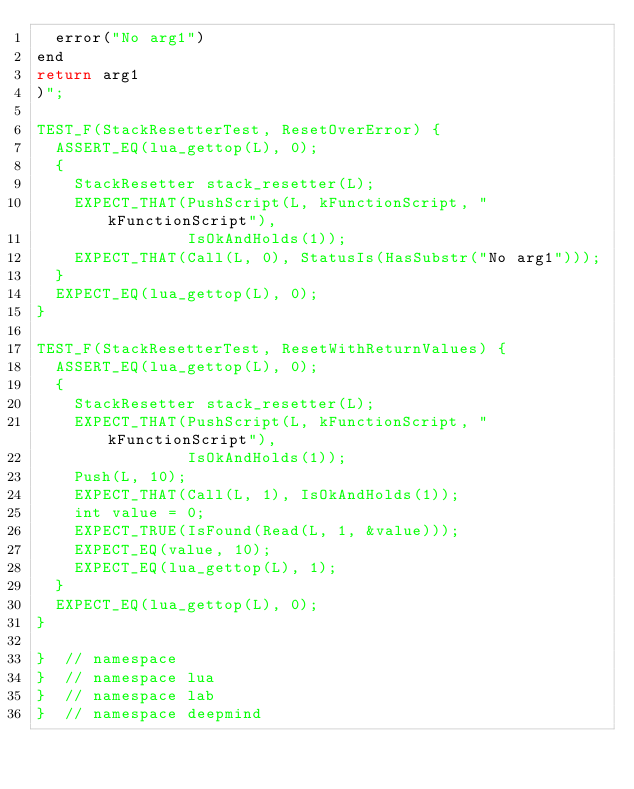Convert code to text. <code><loc_0><loc_0><loc_500><loc_500><_C++_>  error("No arg1")
end
return arg1
)";

TEST_F(StackResetterTest, ResetOverError) {
  ASSERT_EQ(lua_gettop(L), 0);
  {
    StackResetter stack_resetter(L);
    EXPECT_THAT(PushScript(L, kFunctionScript, "kFunctionScript"),
                IsOkAndHolds(1));
    EXPECT_THAT(Call(L, 0), StatusIs(HasSubstr("No arg1")));
  }
  EXPECT_EQ(lua_gettop(L), 0);
}

TEST_F(StackResetterTest, ResetWithReturnValues) {
  ASSERT_EQ(lua_gettop(L), 0);
  {
    StackResetter stack_resetter(L);
    EXPECT_THAT(PushScript(L, kFunctionScript, "kFunctionScript"),
                IsOkAndHolds(1));
    Push(L, 10);
    EXPECT_THAT(Call(L, 1), IsOkAndHolds(1));
    int value = 0;
    EXPECT_TRUE(IsFound(Read(L, 1, &value)));
    EXPECT_EQ(value, 10);
    EXPECT_EQ(lua_gettop(L), 1);
  }
  EXPECT_EQ(lua_gettop(L), 0);
}

}  // namespace
}  // namespace lua
}  // namespace lab
}  // namespace deepmind
</code> 